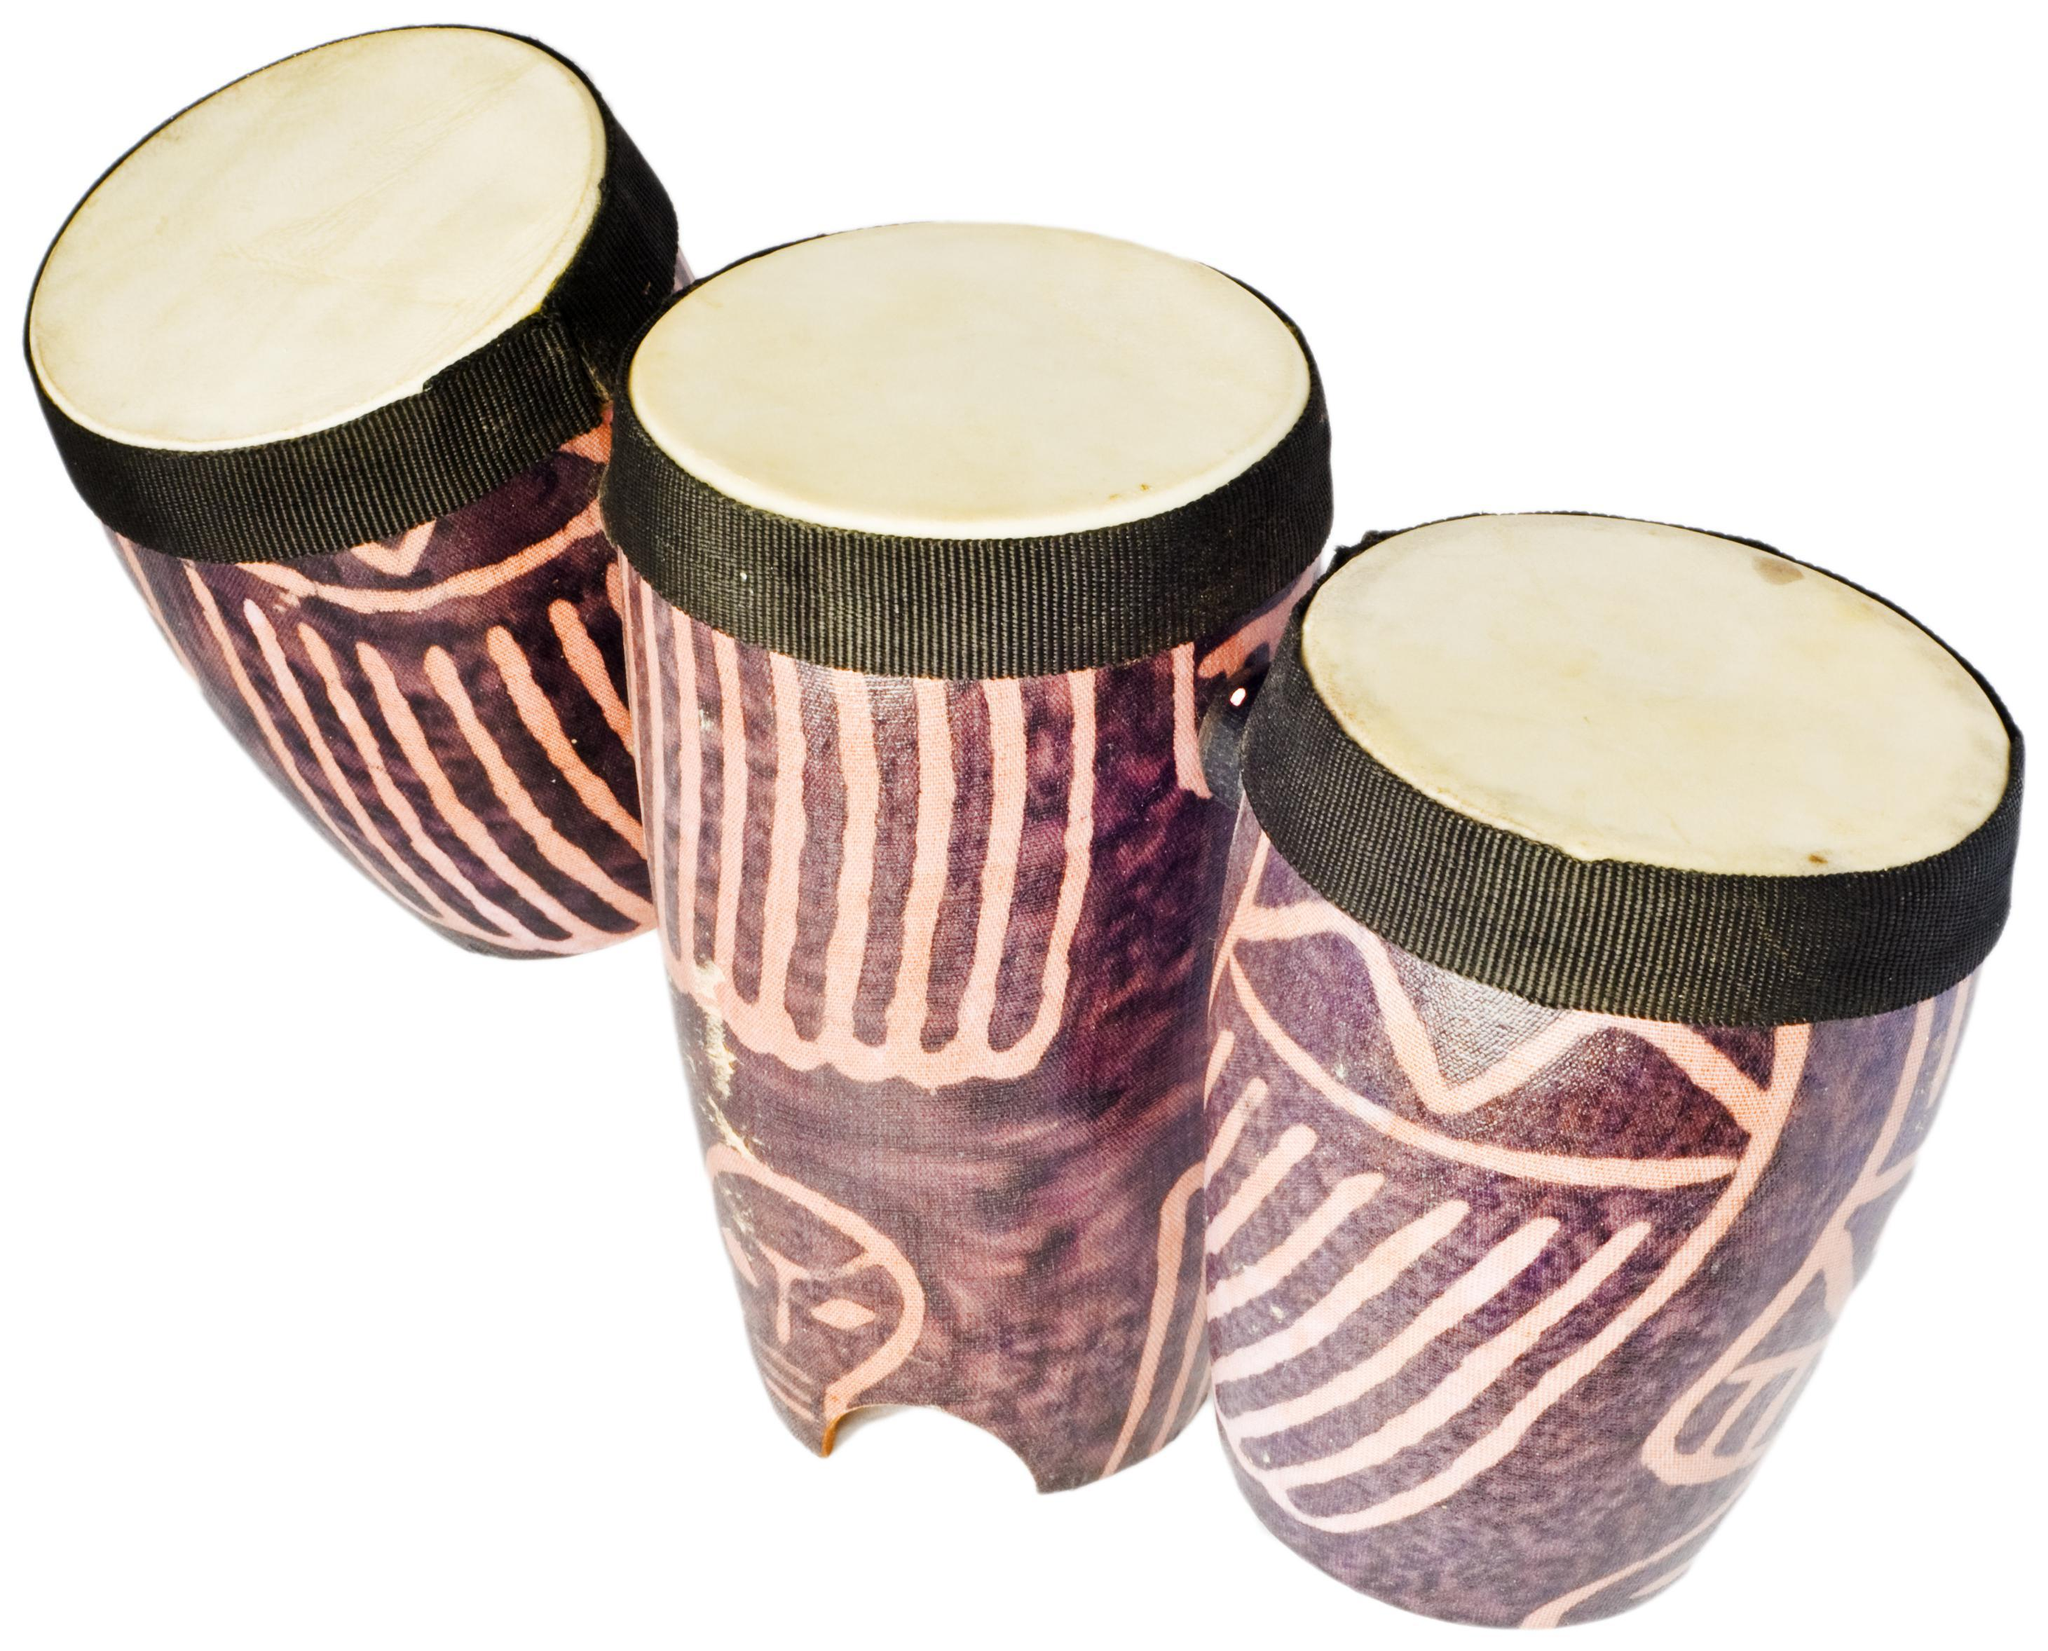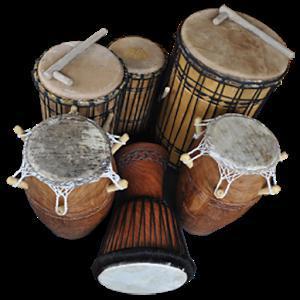The first image is the image on the left, the second image is the image on the right. Assess this claim about the two images: "One image shows a set of three congas and the other shows a single conga drum.". Correct or not? Answer yes or no. No. The first image is the image on the left, the second image is the image on the right. Analyze the images presented: Is the assertion "The left image contains a neat row of three brown drums, and the right image features a single upright brown drum." valid? Answer yes or no. No. 